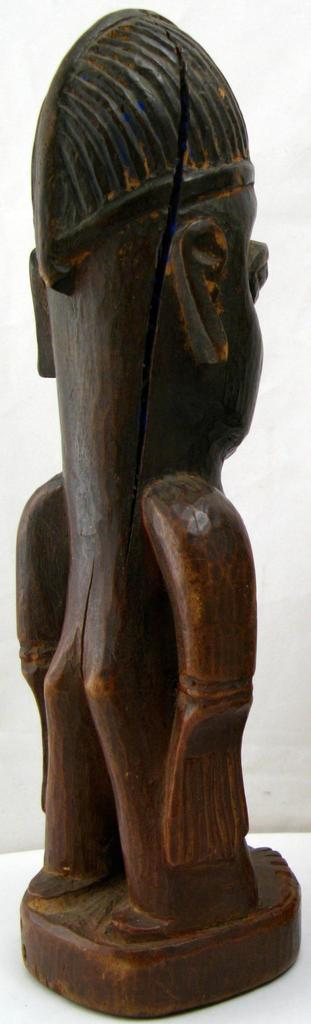What type of object is the main subject in the image? There is a wooden sculpture in the image. What grade of popcorn is being served with the wooden sculpture in the image? There is no popcorn present in the image, and therefore no grade of popcorn can be determined. 